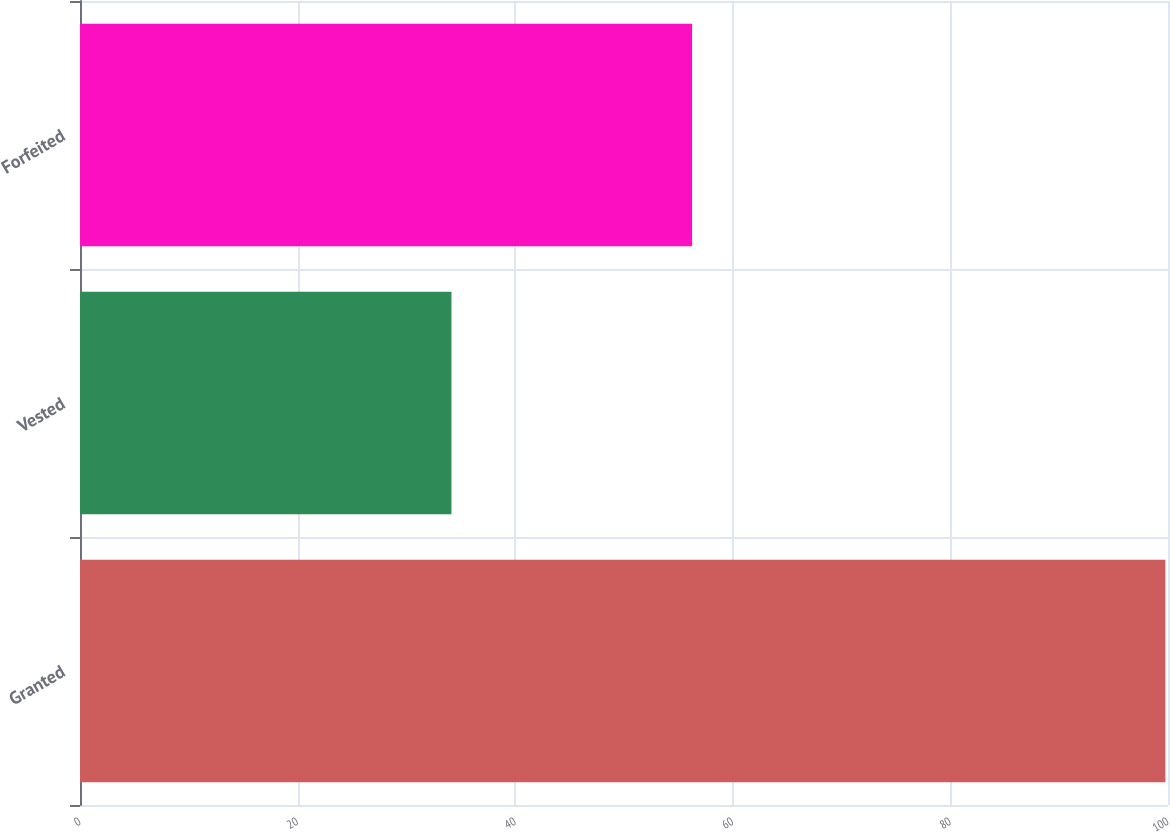<chart> <loc_0><loc_0><loc_500><loc_500><bar_chart><fcel>Granted<fcel>Vested<fcel>Forfeited<nl><fcel>99.76<fcel>34.14<fcel>56.26<nl></chart> 